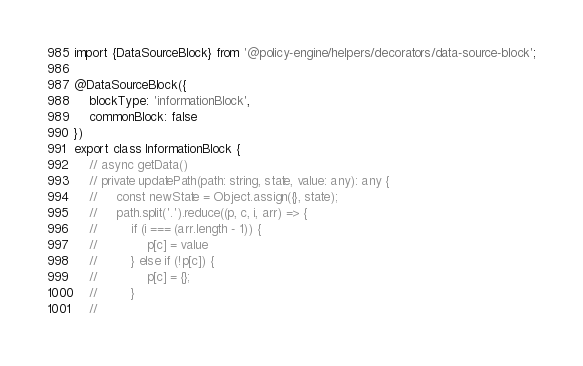Convert code to text. <code><loc_0><loc_0><loc_500><loc_500><_TypeScript_>import {DataSourceBlock} from '@policy-engine/helpers/decorators/data-source-block';

@DataSourceBlock({
    blockType: 'informationBlock',
    commonBlock: false
})
export class InformationBlock {
    // async getData()
    // private updatePath(path: string, state, value: any): any {
    //     const newState = Object.assign({}, state);
    //     path.split('.').reduce((p, c, i, arr) => {
    //         if (i === (arr.length - 1)) {
    //             p[c] = value
    //         } else if (!p[c]) {
    //             p[c] = {};
    //         }
    //</code> 